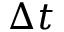<formula> <loc_0><loc_0><loc_500><loc_500>\Delta t</formula> 